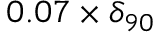<formula> <loc_0><loc_0><loc_500><loc_500>0 . 0 7 \times \delta _ { 9 0 }</formula> 